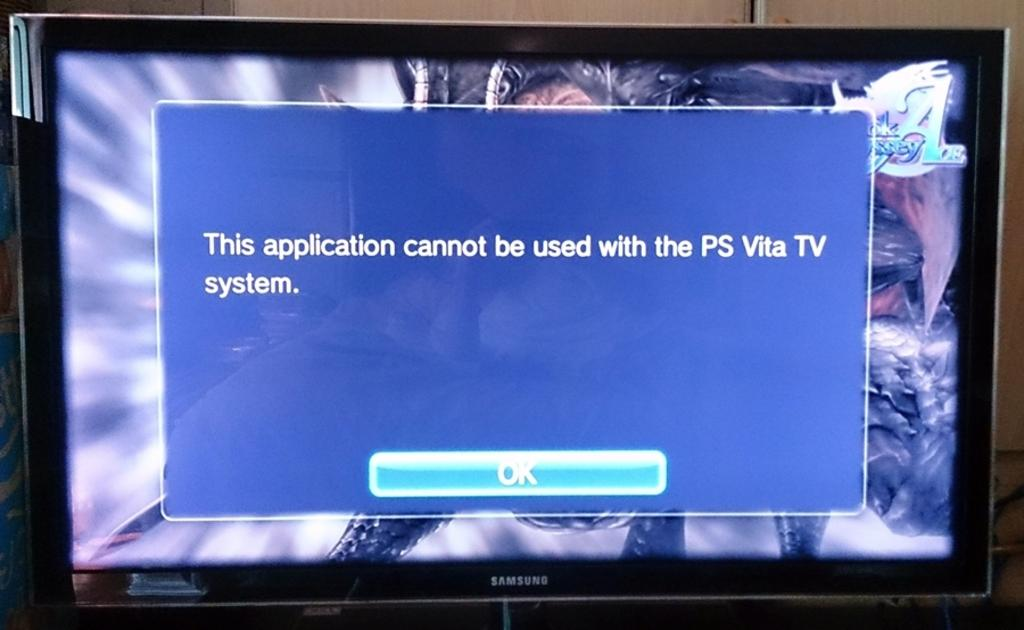<image>
Present a compact description of the photo's key features. a Samsung computer monitor open to a screen reading "This application" 